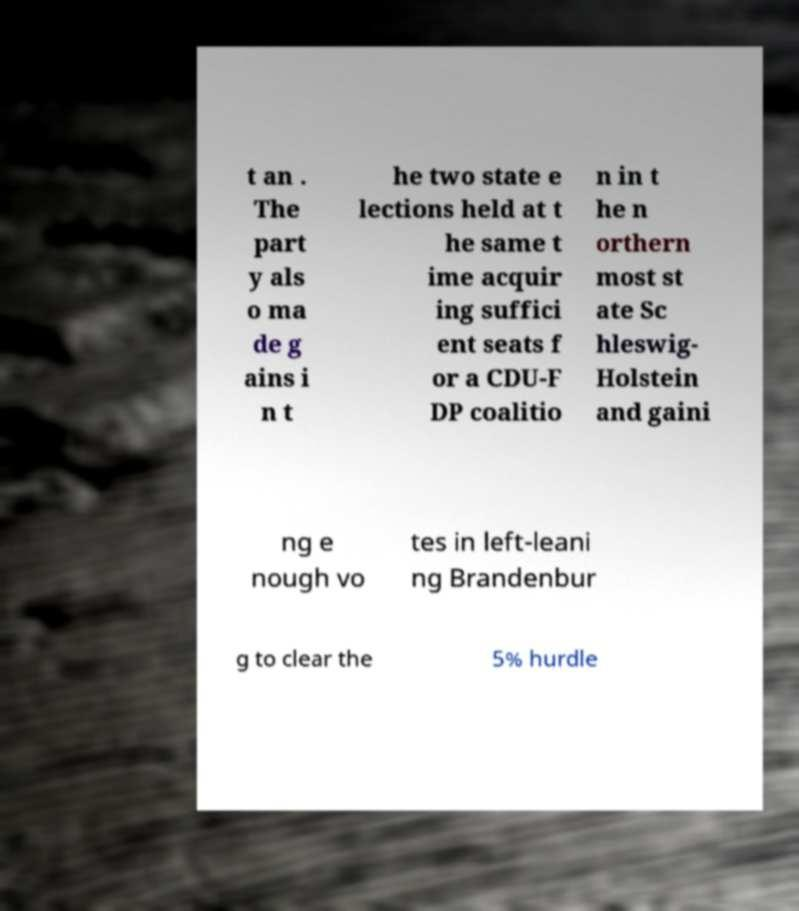For documentation purposes, I need the text within this image transcribed. Could you provide that? t an . The part y als o ma de g ains i n t he two state e lections held at t he same t ime acquir ing suffici ent seats f or a CDU-F DP coalitio n in t he n orthern most st ate Sc hleswig- Holstein and gaini ng e nough vo tes in left-leani ng Brandenbur g to clear the 5% hurdle 